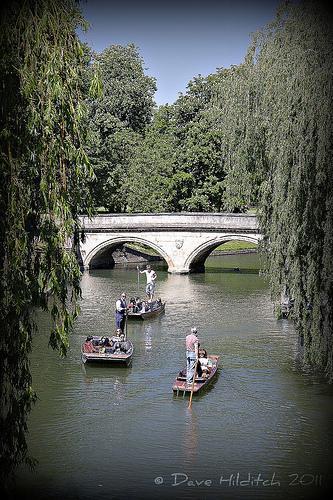How many boatmen are there?
Give a very brief answer. 3. 